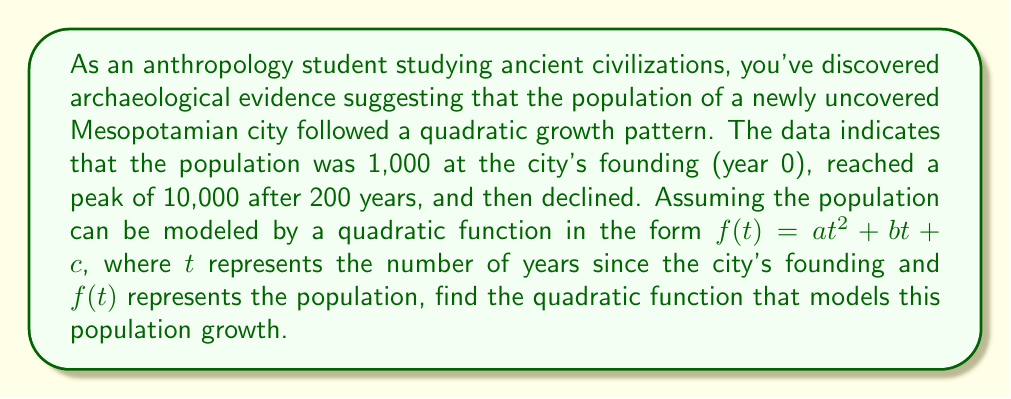Help me with this question. Let's approach this step-by-step:

1) We know the quadratic function is in the form $f(t) = at^2 + bt + c$

2) We have three pieces of information to use:
   a) At $t = 0$, $f(0) = 1,000$
   b) At $t = 200$, $f(200) = 10,000$
   c) The vertex of the parabola is at $(200, 10,000)$

3) From condition (a):
   $f(0) = a(0)^2 + b(0) + c = c = 1,000$

4) The general formula for the axis of symmetry of a parabola is $t = -\frac{b}{2a}$
   Since we know the vertex is at $t = 200$, we can say:
   $200 = -\frac{b}{2a}$
   $b = -400a$

5) Now we can use condition (b):
   $10,000 = a(200)^2 + b(200) + 1,000$
   $10,000 = 40,000a - 80,000a + 1,000$
   $9,000 = -40,000a$
   $a = -\frac{9}{4,000} = -0.00225$

6) Now we can find $b$:
   $b = -400a = -400(-0.00225) = 0.9$

Therefore, the quadratic function is:
$f(t) = -0.00225t^2 + 0.9t + 1,000$
Answer: $f(t) = -0.00225t^2 + 0.9t + 1,000$ 